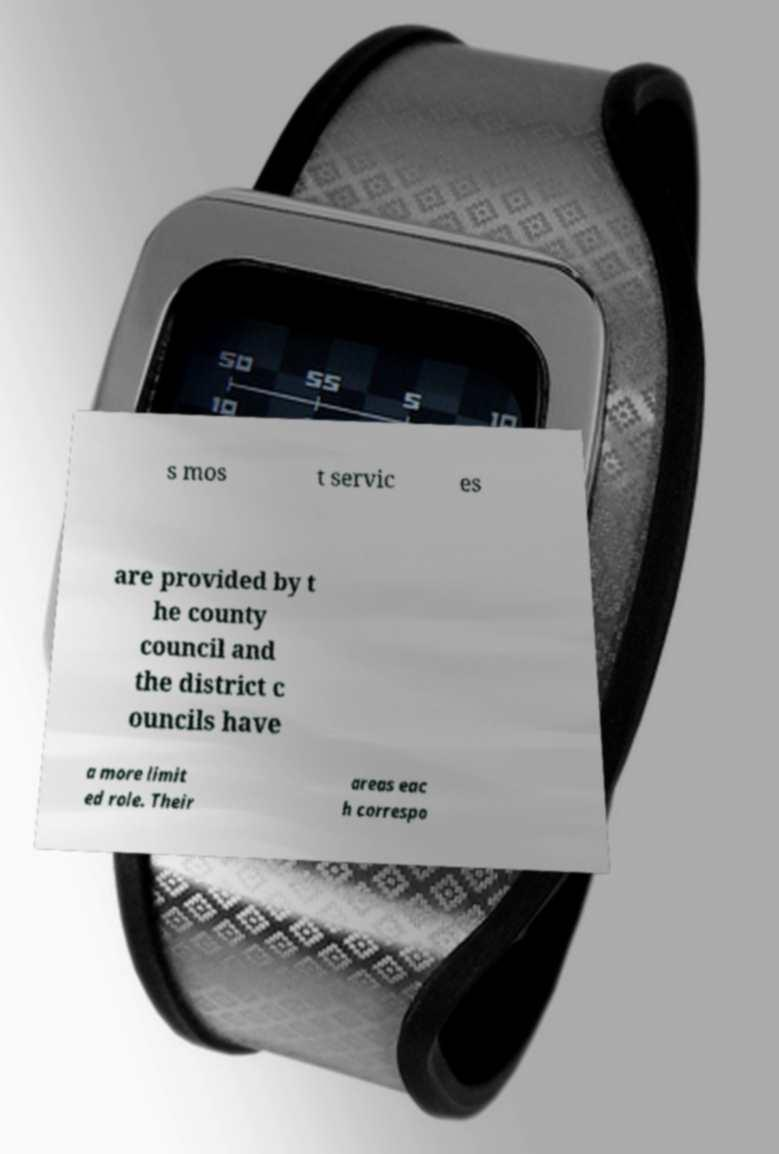I need the written content from this picture converted into text. Can you do that? s mos t servic es are provided by t he county council and the district c ouncils have a more limit ed role. Their areas eac h correspo 